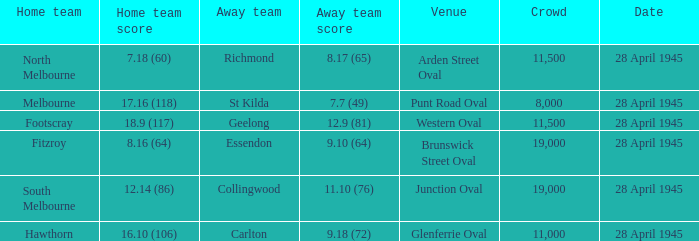Which home team has an Away team of essendon? 8.16 (64). 